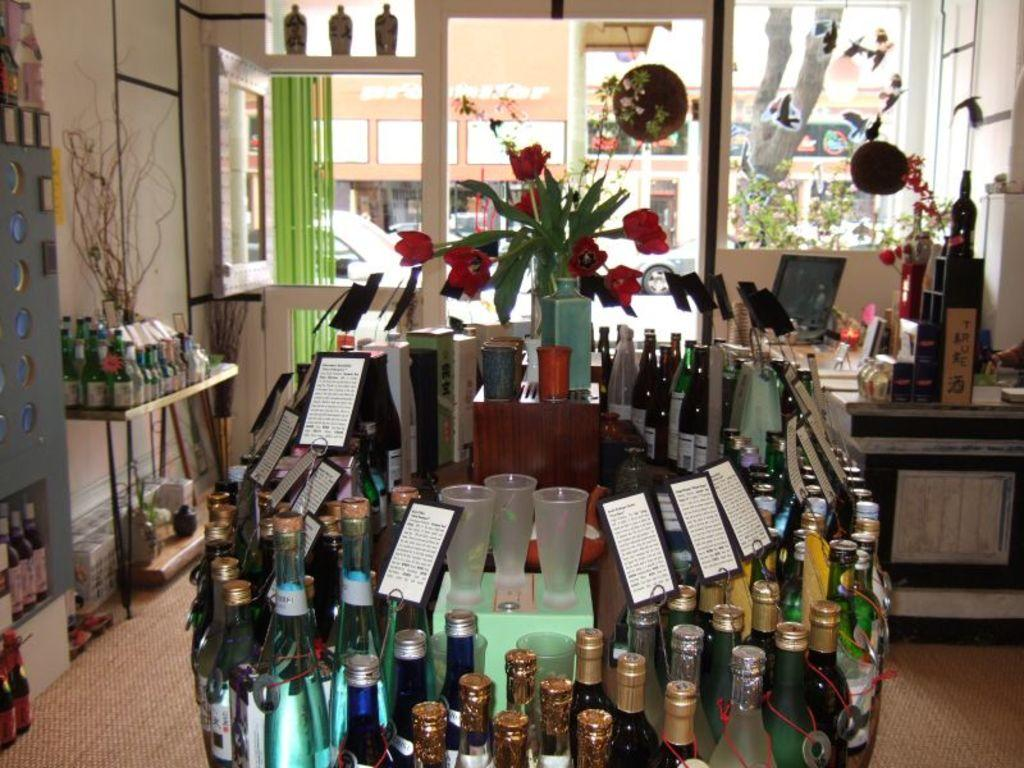What objects can be seen in the image that are typically used for holding liquids? There are bottles in the image that are typically used for holding liquids. What other object can be seen in the image that is not used for holding liquids? There is a flower vase in the image that is not used for holding liquids. What type of furniture is present in the image? There is a table in the image. What electronic device is present on the table? A monitor is present on the table. What type of knee can be seen in the image? There is no knee present in the image. How does the love between the two objects in the image manifest? There is no indication of love between any objects in the image. 